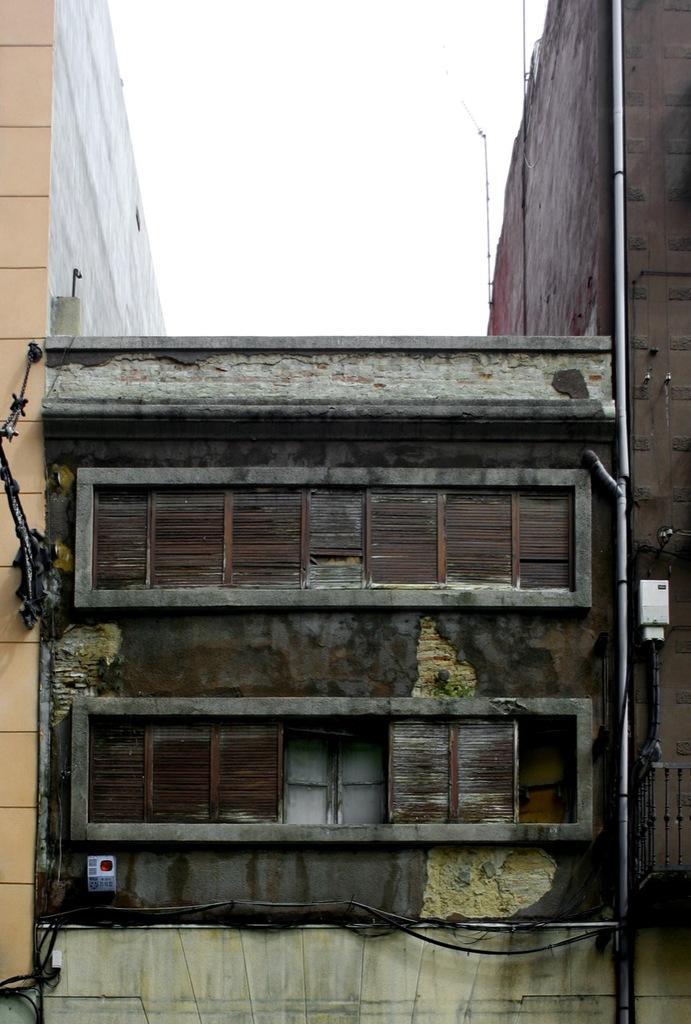Please provide a concise description of this image. In this image we can see buildings, windows, pipelines and sky. 